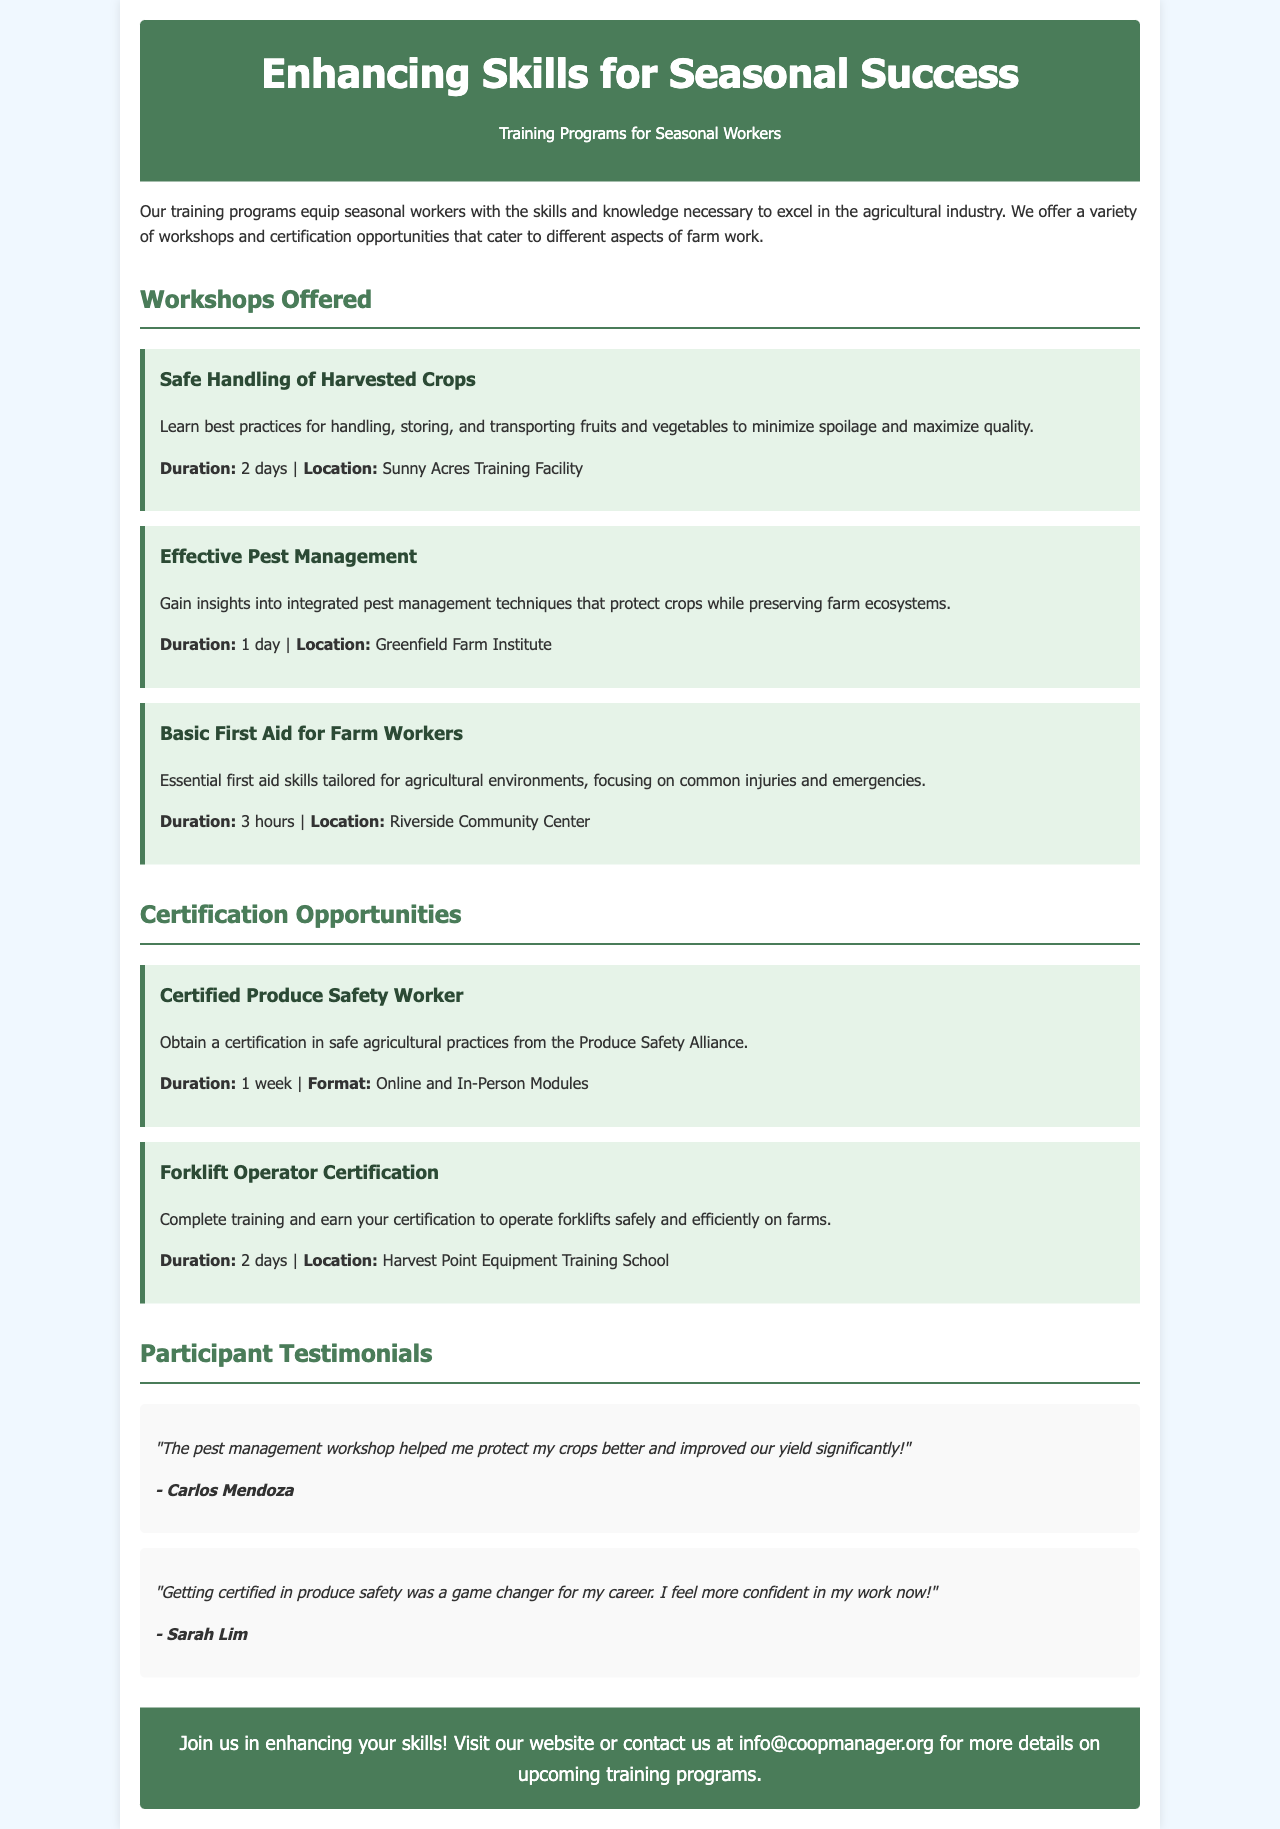What is the title of the brochure? The title of the brochure is prominently displayed at the top of the document, indicating its main focus.
Answer: Enhancing Skills for Seasonal Success What certification is offered for Produce Safety? The document mentions a specific certification related to produce safety in the certification section.
Answer: Certified Produce Safety Worker How long is the Safe Handling of Harvested Crops workshop? The duration of the workshop is noted next to its description, outlining how long participants can expect to spend in training.
Answer: 2 days What feedback did Carlos Mendoza provide? A participant's testimonial included in the document expresses their satisfaction with a specific workshop, contributing to understanding the impact of the training.
Answer: "The pest management workshop helped me protect my crops better and improved our yield significantly!" How many hours is the Basic First Aid for Farm Workers workshop? The document outlines the length of this specific workshop, giving potential participants an idea of what to expect time-wise.
Answer: 3 hours What is the location for the Forklift Operator Certification training? The location for this certification is specified in the brochure, aiding workers in planning their attendance.
Answer: Harvest Point Equipment Training School What is the main subject of the Effective Pest Management workshop? This question pertains to the focus of one of the workshops, helping potential attendees understand what they will learn.
Answer: Integrated pest management techniques How can participants get more information about the training programs? The document features a call to action at the end, providing instructions on how to obtain further details.
Answer: Visit our website or contact us at info@coopmanager.org 